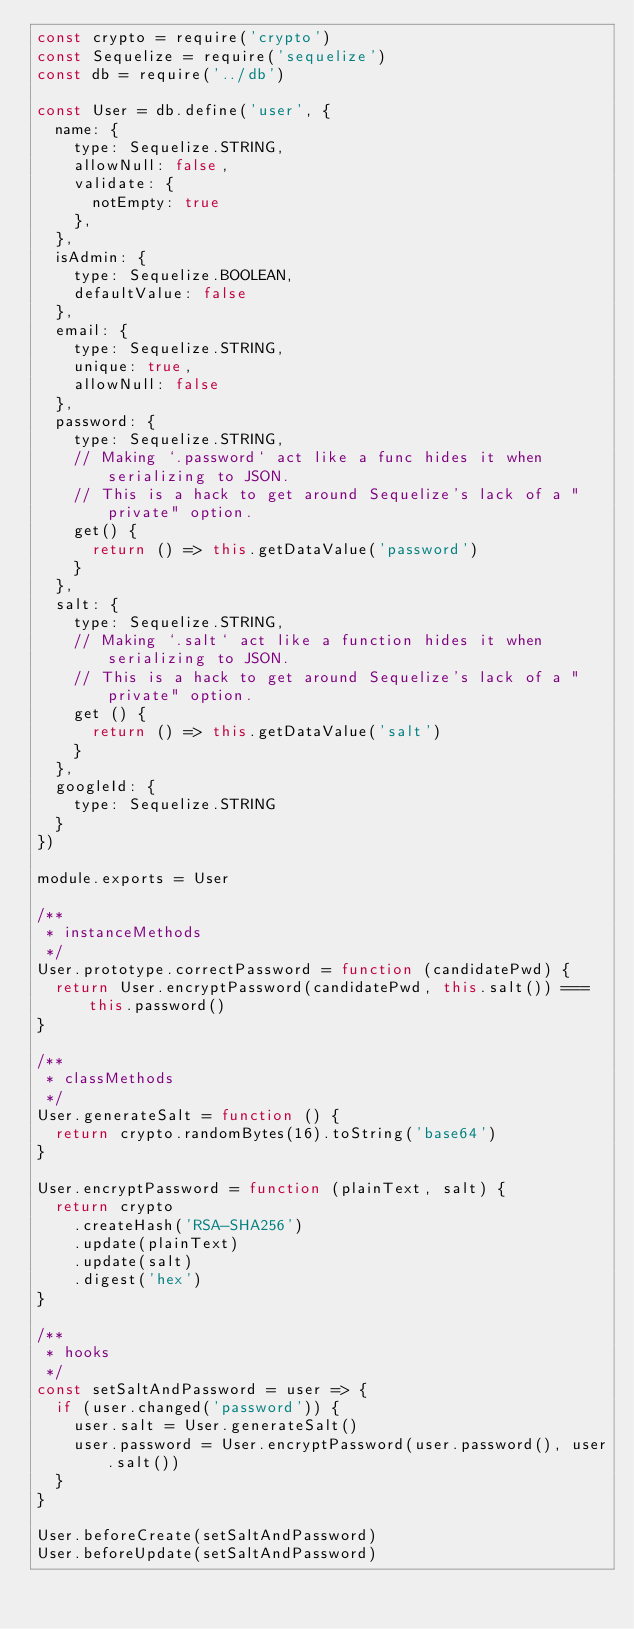Convert code to text. <code><loc_0><loc_0><loc_500><loc_500><_JavaScript_>const crypto = require('crypto')
const Sequelize = require('sequelize')
const db = require('../db')

const User = db.define('user', {
  name: {
    type: Sequelize.STRING,
    allowNull: false,
    validate: {
      notEmpty: true
    },
  },
  isAdmin: {
    type: Sequelize.BOOLEAN,
    defaultValue: false
  },
  email: {
    type: Sequelize.STRING,
    unique: true,
    allowNull: false
  },
  password: {
    type: Sequelize.STRING,
    // Making `.password` act like a func hides it when serializing to JSON.
    // This is a hack to get around Sequelize's lack of a "private" option.
    get() {
      return () => this.getDataValue('password')
    }
  },
  salt: {
    type: Sequelize.STRING,
    // Making `.salt` act like a function hides it when serializing to JSON.
    // This is a hack to get around Sequelize's lack of a "private" option.
    get () {
      return () => this.getDataValue('salt')
    }
  },
  googleId: {
    type: Sequelize.STRING
  }
})

module.exports = User

/**
 * instanceMethods
 */
User.prototype.correctPassword = function (candidatePwd) {
  return User.encryptPassword(candidatePwd, this.salt()) === this.password()
}

/**
 * classMethods
 */
User.generateSalt = function () {
  return crypto.randomBytes(16).toString('base64')
}

User.encryptPassword = function (plainText, salt) {
  return crypto
    .createHash('RSA-SHA256')
    .update(plainText)
    .update(salt)
    .digest('hex')
}

/**
 * hooks
 */
const setSaltAndPassword = user => {
  if (user.changed('password')) {
    user.salt = User.generateSalt()
    user.password = User.encryptPassword(user.password(), user.salt())
  }
}

User.beforeCreate(setSaltAndPassword)
User.beforeUpdate(setSaltAndPassword)
</code> 